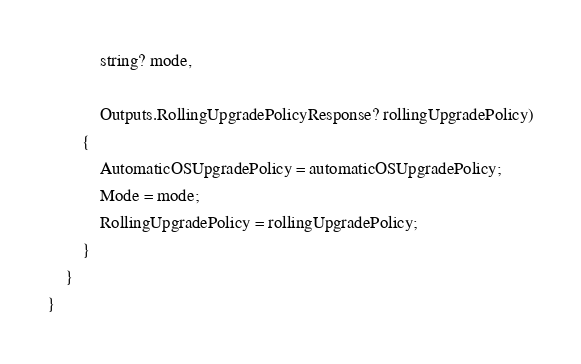Convert code to text. <code><loc_0><loc_0><loc_500><loc_500><_C#_>            string? mode,

            Outputs.RollingUpgradePolicyResponse? rollingUpgradePolicy)
        {
            AutomaticOSUpgradePolicy = automaticOSUpgradePolicy;
            Mode = mode;
            RollingUpgradePolicy = rollingUpgradePolicy;
        }
    }
}
</code> 